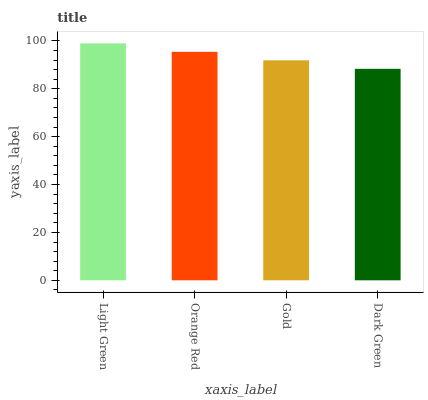Is Dark Green the minimum?
Answer yes or no. Yes. Is Light Green the maximum?
Answer yes or no. Yes. Is Orange Red the minimum?
Answer yes or no. No. Is Orange Red the maximum?
Answer yes or no. No. Is Light Green greater than Orange Red?
Answer yes or no. Yes. Is Orange Red less than Light Green?
Answer yes or no. Yes. Is Orange Red greater than Light Green?
Answer yes or no. No. Is Light Green less than Orange Red?
Answer yes or no. No. Is Orange Red the high median?
Answer yes or no. Yes. Is Gold the low median?
Answer yes or no. Yes. Is Dark Green the high median?
Answer yes or no. No. Is Light Green the low median?
Answer yes or no. No. 